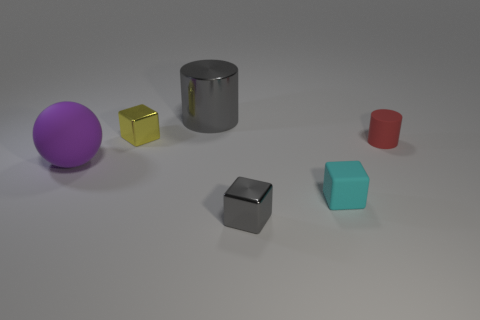How big is the gray metallic object behind the gray object in front of the big matte sphere?
Make the answer very short. Large. Is the shiny cylinder the same color as the rubber cylinder?
Offer a very short reply. No. How many metal objects are small gray blocks or big gray things?
Offer a very short reply. 2. How many big purple objects are there?
Offer a very short reply. 1. Are the tiny object that is to the left of the gray cube and the gray thing on the left side of the small gray object made of the same material?
Your response must be concise. Yes. The big thing that is the same shape as the small red matte object is what color?
Offer a terse response. Gray. What is the material of the cube on the left side of the gray object that is in front of the big metallic object?
Your response must be concise. Metal. Is the shape of the tiny metal thing in front of the red cylinder the same as the big object behind the tiny matte cylinder?
Keep it short and to the point. No. There is a block that is both to the left of the cyan block and in front of the sphere; what size is it?
Ensure brevity in your answer.  Small. How many other objects are the same color as the tiny matte cube?
Provide a short and direct response. 0. 